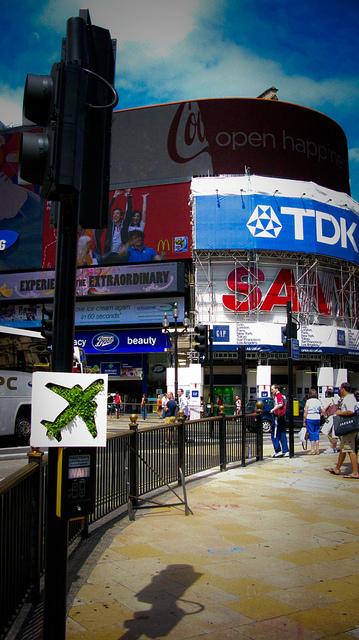Is there a street light?
Answer briefly. Yes. What is on green object on the white sign?
Give a very brief answer. Airplane. What famous soda company has a logo on the building?
Be succinct. Coca cola. 